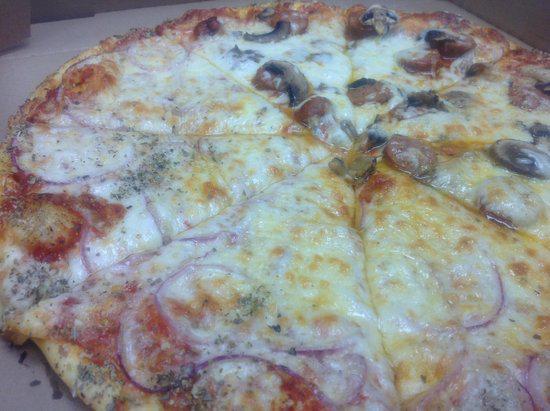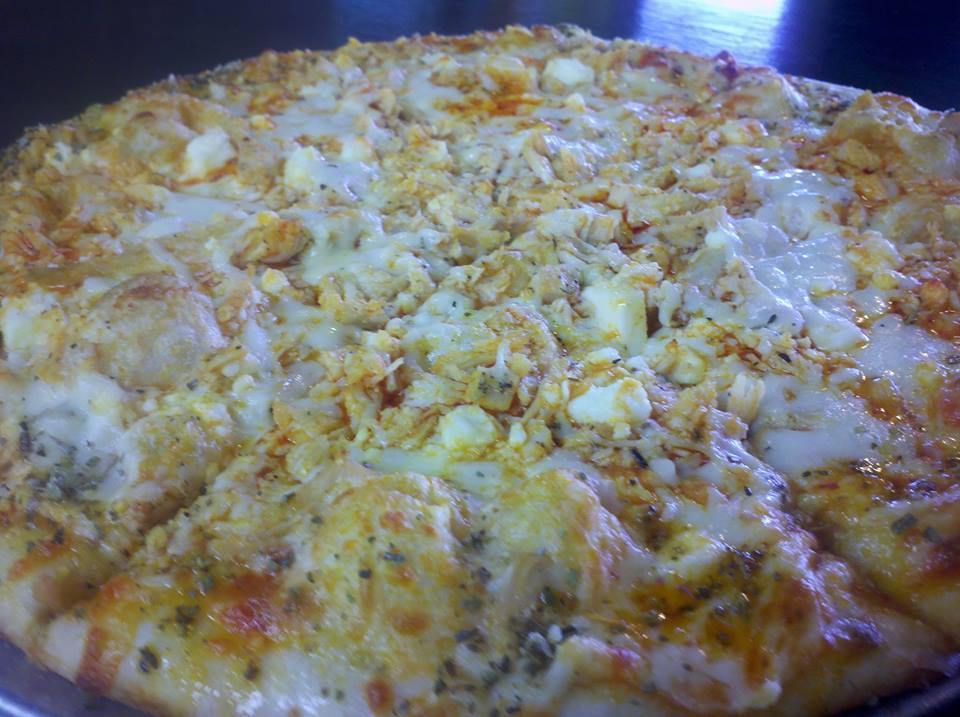The first image is the image on the left, the second image is the image on the right. For the images displayed, is the sentence "The left and right image contains the same number of full pizzas." factually correct? Answer yes or no. Yes. The first image is the image on the left, the second image is the image on the right. Assess this claim about the two images: "The left image shows a rectangular metal tray containing something that is mostly yellow.". Correct or not? Answer yes or no. No. 